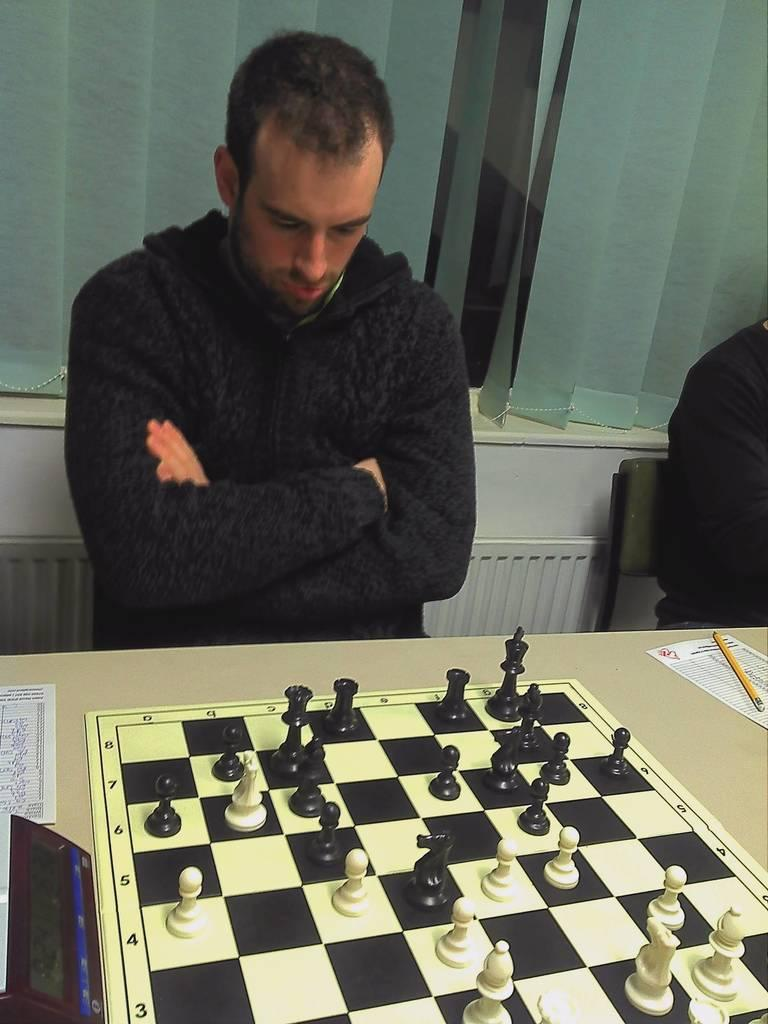Who is present in the image? There is a man in the image. What is the man doing in the image? The man is in front of a chessboard. Where is the chessboard located? The chessboard is on a table. What can be seen behind the man? There is a window behind the man. Is there any window treatment present in the image? Yes, there is a curtain associated with the window. What type of box is the man using to fight in the image? There is no box or fighting depicted in the image; the man is simply standing in front of a chessboard. 